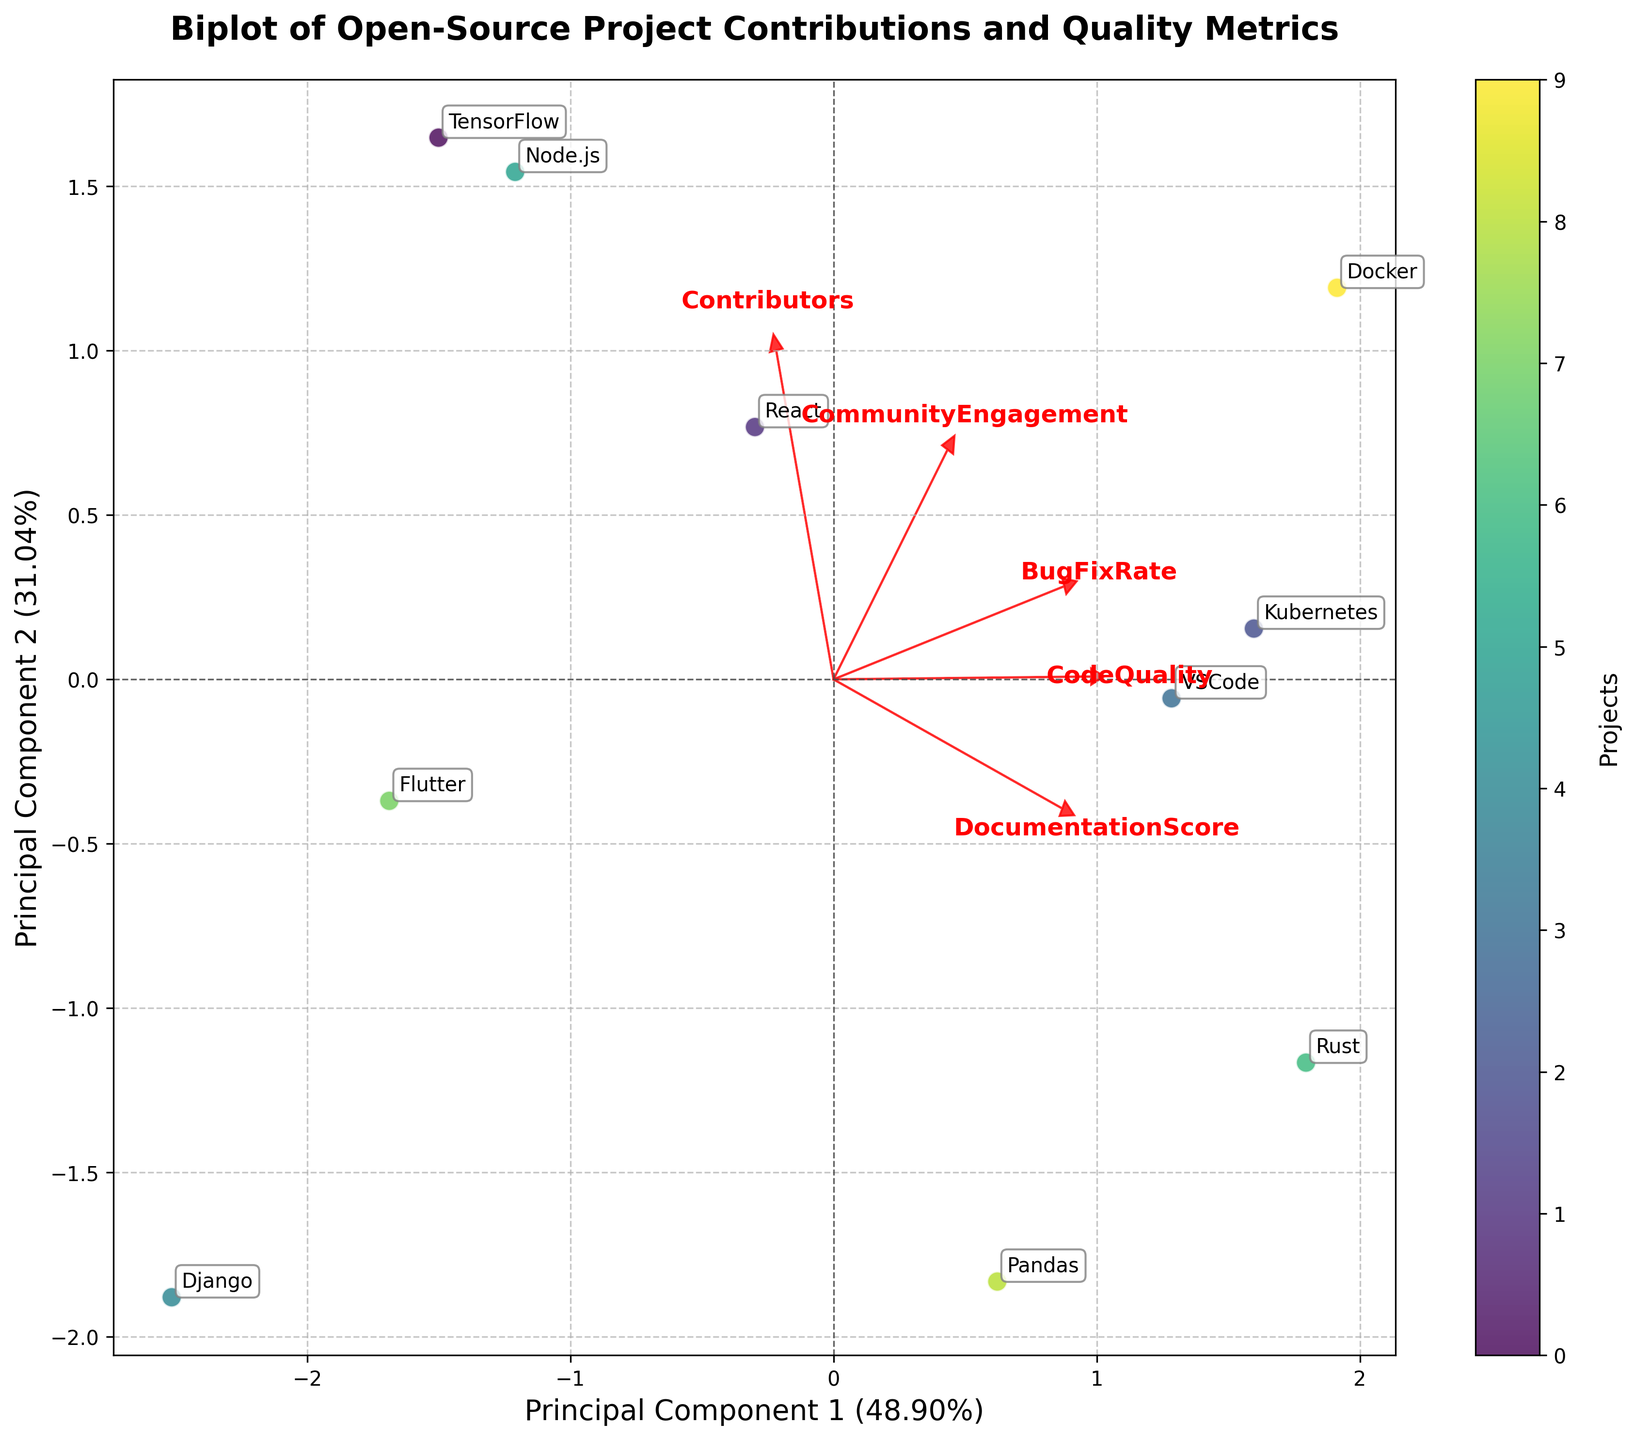What is the title of the plot? The title is located at the top center of the plot and reads "Biplot of Open-Source Project Contributions and Quality Metrics".
Answer: Biplot of Open-Source Project Contributions and Quality Metrics How many projects are analyzed in the plot? Each point on the scatter represents a project. By counting the points or referring to the list of project labels, we see there are 10 projects.
Answer: 10 Which metric is most closely associated with Principal Component 1? Look at the arrows representing the loadings (contributions of variables to the principal components). The arrow pointing most horizontal along Principal Component 1 axis suggests the metric. Here "Contributors" has the longest horizontal arrow.
Answer: Contributors What range of values do the principal components cover on the x-axis and y-axis? The x-axis (Principal Component 1) ranges from about -2.5 to 2.5, and the y-axis (Principal Component 2) ranges from about -2 to 2.
Answer: x-axis: -2.5 to 2.5, y-axis: -2 to 2 Which project is plotted highest along Principal Component 2? By looking at the vertical placement of points, "VSCode" is plotted highest along the y-axis.
Answer: VSCode Which project has the most significant impact on 'CommunityEngagement' according to the loading plot? Check the end points of arrows; "CommunityEngagement" arrow points closely to 'React', suggesting React has a significant impact on it.
Answer: React How do 'CodeQuality' and 'BugFixRate' relate to each other in the plot? The arrows for these metrics are quite close, indicating they are correlated and tend to move in the same direction in the principal component space.
Answer: They are positively correlated Which projects appear most similar based on the principal components? Look for points that are close to each other; 'Kubernetes' and 'Docker' are relatively close, meaning their metrics are quite similar.
Answer: Kubernetes and Docker What does the closeness of the arrows for 'Contributors' and 'CommunityEngagement' suggest? Arrows pointing in similar directions indicate that these factors are positively correlated, suggesting projects with more contributors tend to have higher community engagement.
Answer: Positive correlation Which metric has the least influence on Principal Component 2? The arrow for the metric closest to being horizontal to the x-axis has the least influence on Principal Component 2. 'Contributors' appears to be the flattest, suggesting it has the least influence on PC2.
Answer: Contributors 